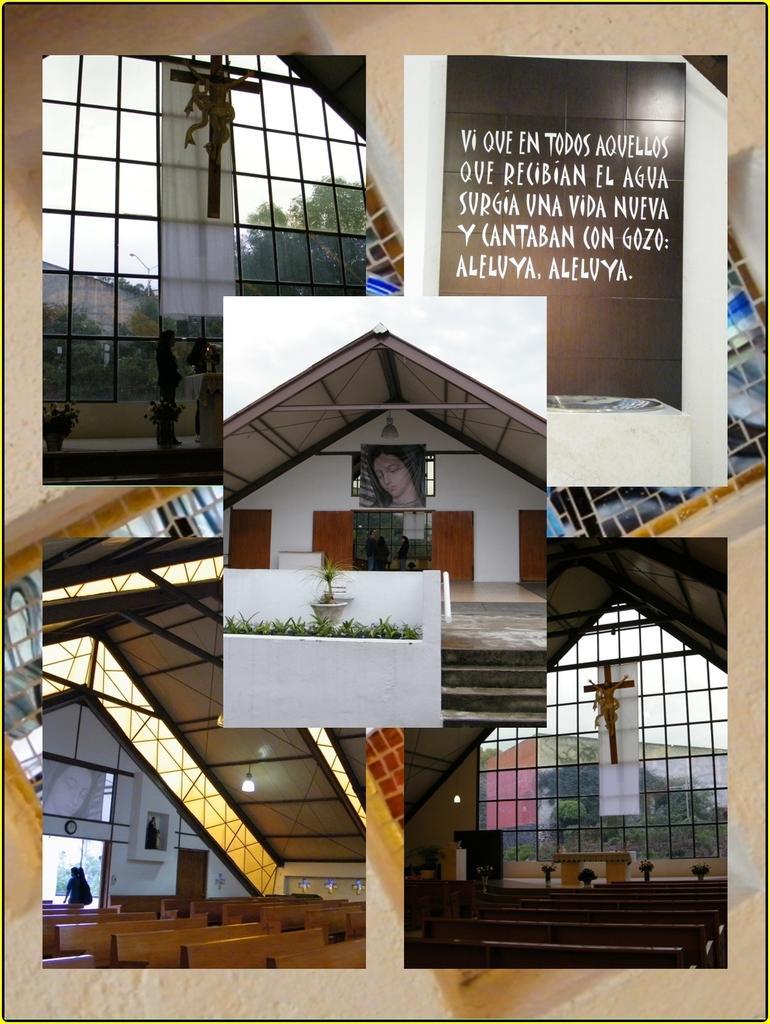How would you summarize this image in a sentence or two? In this image we can see a collage of pictures in which we can see some cross, a group of chairs, some test, photo frames on the wall. In the background, we can see trees and the sky. 